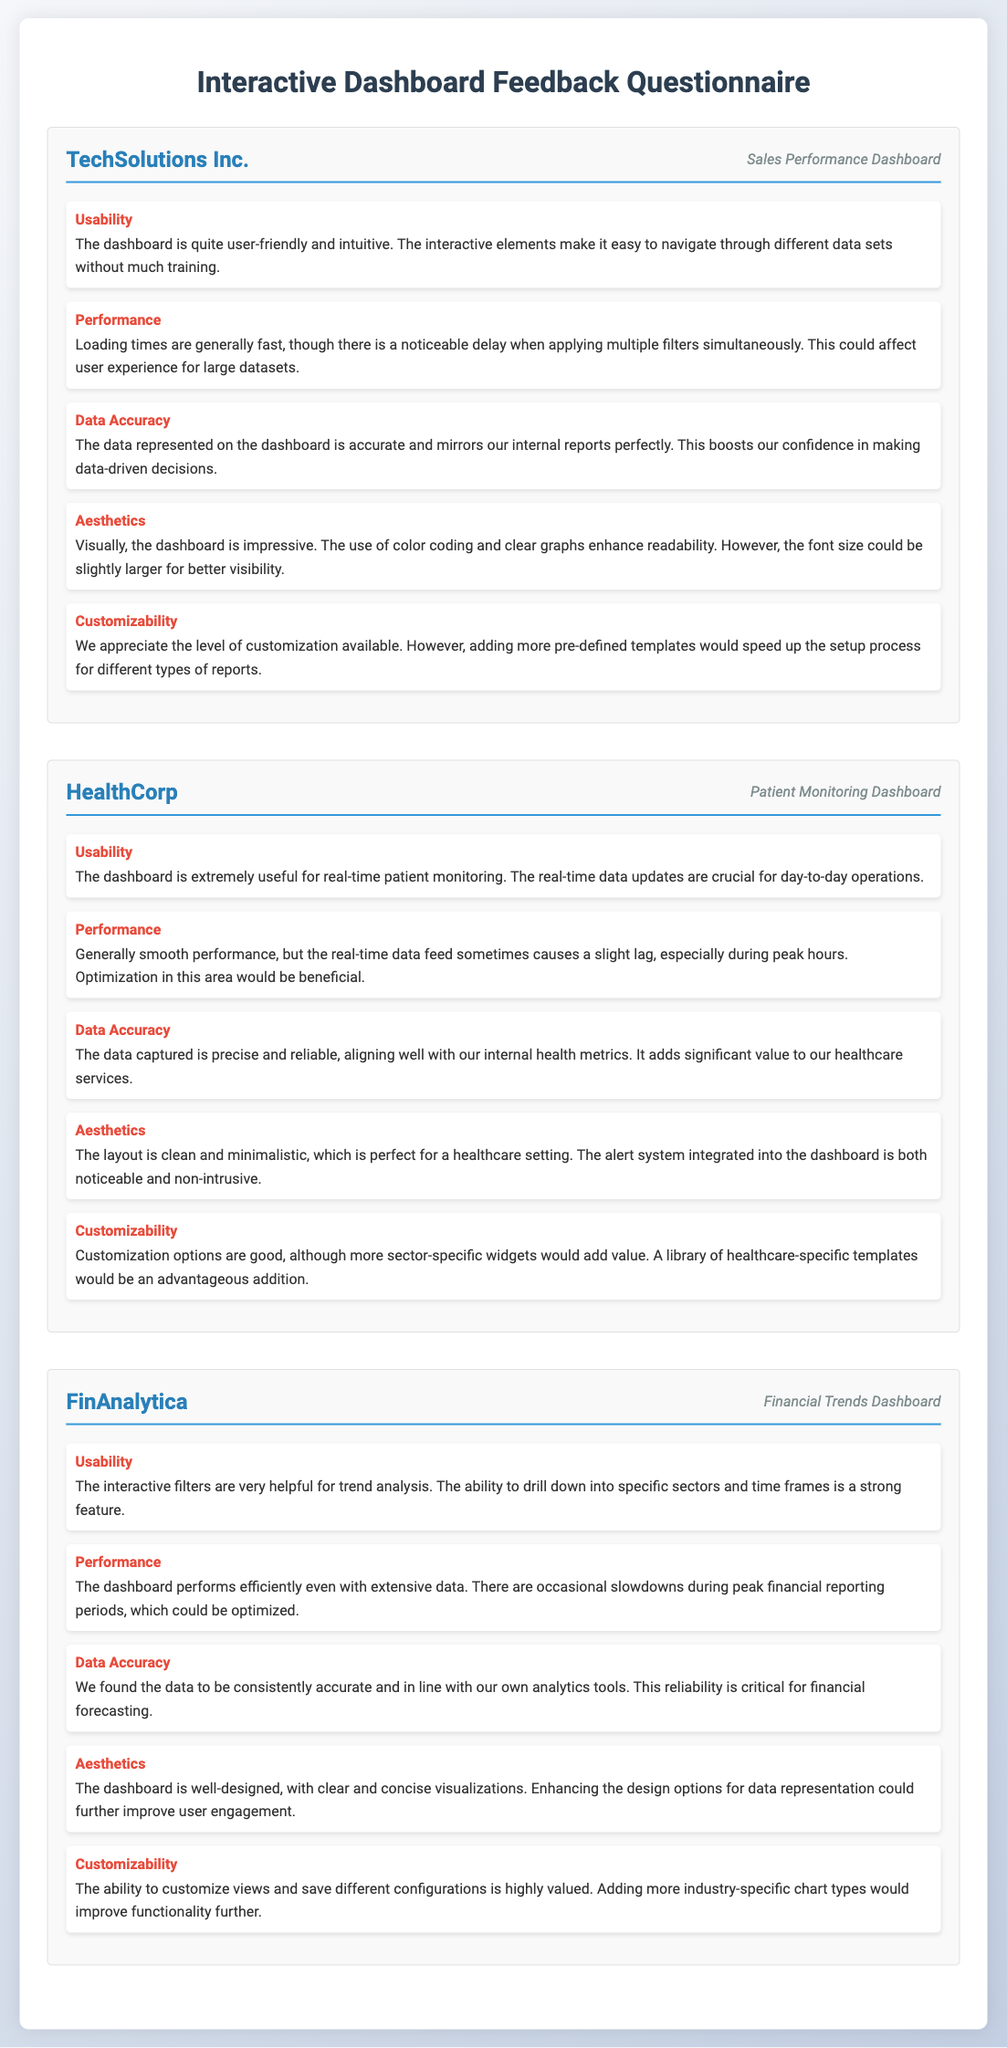What is the name of the client for the Sales Performance Dashboard? The client's name is mentioned in the header of the section, which is TechSolutions Inc.
Answer: TechSolutions Inc How many feedback aspects are listed for the Patient Monitoring Dashboard? Each client section has five feedback aspects listed, and there is one section for the Patient Monitoring Dashboard.
Answer: 5 What is one of the usability feedback comments for the Financial Trends Dashboard? The usability feedback comment for the Financial Trends Dashboard highlights the helpfulness of interactive filters for trend analysis.
Answer: The interactive filters are very helpful for trend analysis Which feature caused noticeable delays for TechSolutions Inc.? The document indicates that there is a noticeable delay when applying multiple filters simultaneously in the dashboard for TechSolutions Inc.
Answer: Applying multiple filters simultaneously What does HealthCorp suggest to improve customization options? HealthCorp suggests that a library of healthcare-specific templates would be an advantageous addition to improve customization options.
Answer: More sector-specific widgets What is the performance issue noted by HealthCorp during peak hours? HealthCorp mentions that the real-time data feed sometimes causes a slight lag during peak hours.
Answer: A slight lag during peak hours 